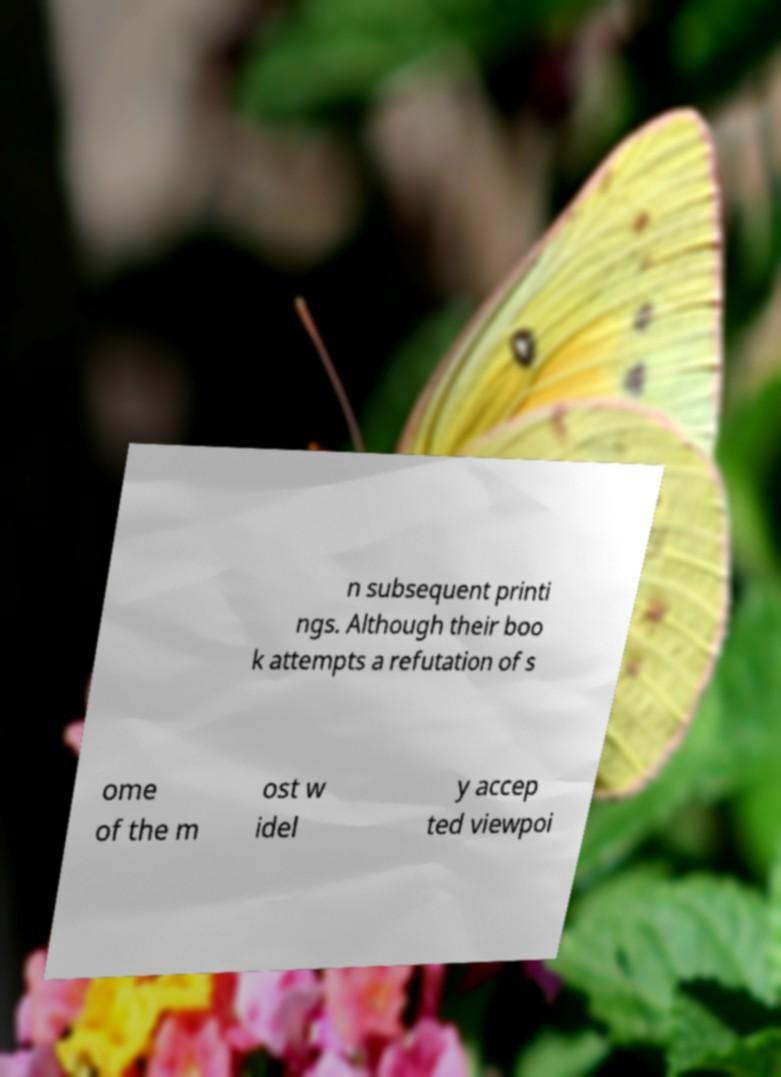Can you read and provide the text displayed in the image?This photo seems to have some interesting text. Can you extract and type it out for me? n subsequent printi ngs. Although their boo k attempts a refutation of s ome of the m ost w idel y accep ted viewpoi 